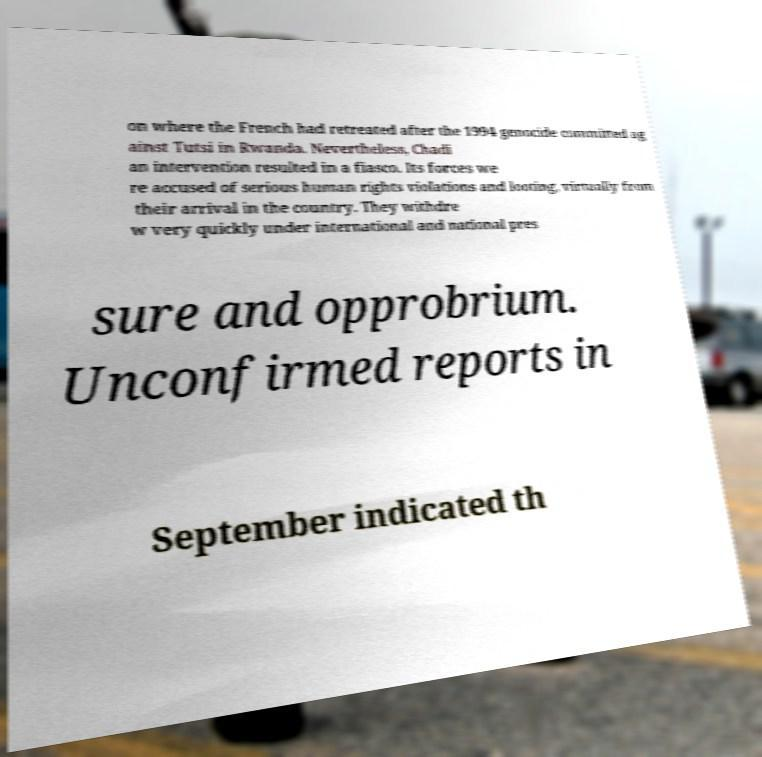Can you accurately transcribe the text from the provided image for me? on where the French had retreated after the 1994 genocide committed ag ainst Tutsi in Rwanda. Nevertheless, Chadi an intervention resulted in a fiasco. Its forces we re accused of serious human rights violations and looting, virtually from their arrival in the country. They withdre w very quickly under international and national pres sure and opprobrium. Unconfirmed reports in September indicated th 